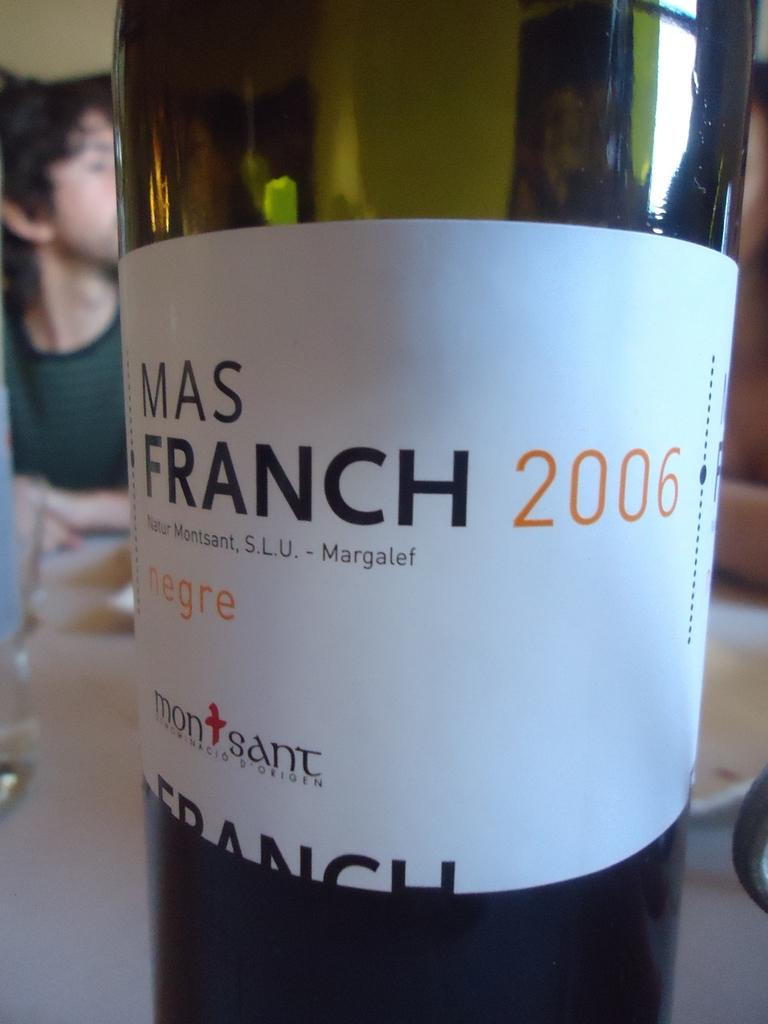What is on the bottle that is visible in the image? There is a sticker on the bottle in the image. Where is the bottle located in the image? The bottle is placed on a table in the image. What can be seen in the background of the image? There are people in the background of the image. How does the earthquake affect the bottle in the image? There is no earthquake present in the image, so its effect on the bottle cannot be determined. 